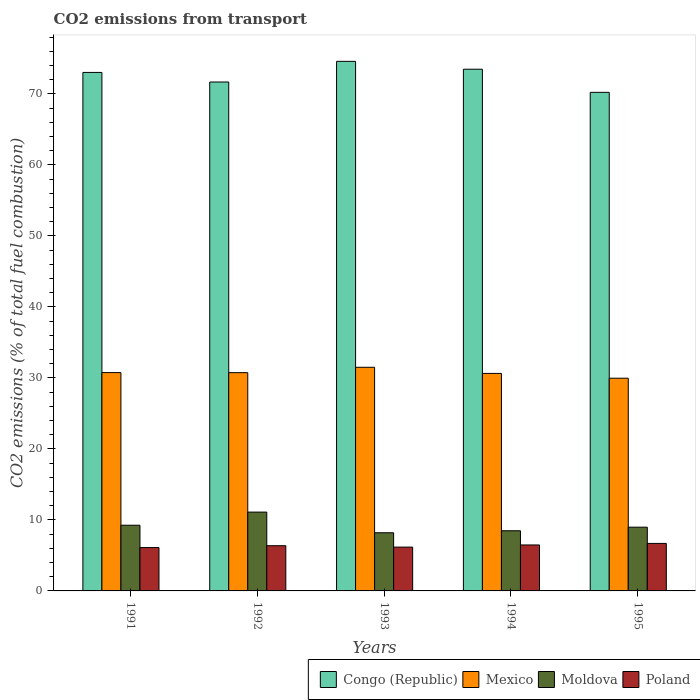How many groups of bars are there?
Your response must be concise. 5. Are the number of bars per tick equal to the number of legend labels?
Your answer should be very brief. Yes. Are the number of bars on each tick of the X-axis equal?
Offer a very short reply. Yes. How many bars are there on the 2nd tick from the left?
Give a very brief answer. 4. What is the label of the 1st group of bars from the left?
Keep it short and to the point. 1991. In how many cases, is the number of bars for a given year not equal to the number of legend labels?
Provide a succinct answer. 0. What is the total CO2 emitted in Mexico in 1991?
Provide a short and direct response. 30.75. Across all years, what is the maximum total CO2 emitted in Congo (Republic)?
Ensure brevity in your answer.  74.58. Across all years, what is the minimum total CO2 emitted in Congo (Republic)?
Your response must be concise. 70.21. In which year was the total CO2 emitted in Poland maximum?
Make the answer very short. 1995. What is the total total CO2 emitted in Moldova in the graph?
Offer a terse response. 45.99. What is the difference between the total CO2 emitted in Poland in 1992 and that in 1994?
Give a very brief answer. -0.1. What is the difference between the total CO2 emitted in Poland in 1993 and the total CO2 emitted in Congo (Republic) in 1994?
Make the answer very short. -67.3. What is the average total CO2 emitted in Congo (Republic) per year?
Your response must be concise. 72.59. In the year 1992, what is the difference between the total CO2 emitted in Poland and total CO2 emitted in Moldova?
Keep it short and to the point. -4.73. What is the ratio of the total CO2 emitted in Mexico in 1991 to that in 1995?
Provide a short and direct response. 1.03. Is the difference between the total CO2 emitted in Poland in 1992 and 1994 greater than the difference between the total CO2 emitted in Moldova in 1992 and 1994?
Keep it short and to the point. No. What is the difference between the highest and the second highest total CO2 emitted in Poland?
Offer a very short reply. 0.22. What is the difference between the highest and the lowest total CO2 emitted in Congo (Republic)?
Your answer should be very brief. 4.36. Is the sum of the total CO2 emitted in Mexico in 1991 and 1995 greater than the maximum total CO2 emitted in Moldova across all years?
Offer a very short reply. Yes. Is it the case that in every year, the sum of the total CO2 emitted in Moldova and total CO2 emitted in Congo (Republic) is greater than the sum of total CO2 emitted in Mexico and total CO2 emitted in Poland?
Your answer should be compact. Yes. What does the 2nd bar from the right in 1991 represents?
Your answer should be very brief. Moldova. Is it the case that in every year, the sum of the total CO2 emitted in Moldova and total CO2 emitted in Poland is greater than the total CO2 emitted in Congo (Republic)?
Provide a short and direct response. No. Are the values on the major ticks of Y-axis written in scientific E-notation?
Your answer should be compact. No. Does the graph contain grids?
Provide a short and direct response. No. How are the legend labels stacked?
Offer a terse response. Horizontal. What is the title of the graph?
Keep it short and to the point. CO2 emissions from transport. Does "Andorra" appear as one of the legend labels in the graph?
Offer a very short reply. No. What is the label or title of the X-axis?
Provide a succinct answer. Years. What is the label or title of the Y-axis?
Provide a short and direct response. CO2 emissions (% of total fuel combustion). What is the CO2 emissions (% of total fuel combustion) in Congo (Republic) in 1991?
Keep it short and to the point. 73.02. What is the CO2 emissions (% of total fuel combustion) in Mexico in 1991?
Your response must be concise. 30.75. What is the CO2 emissions (% of total fuel combustion) of Moldova in 1991?
Provide a short and direct response. 9.25. What is the CO2 emissions (% of total fuel combustion) in Poland in 1991?
Provide a succinct answer. 6.1. What is the CO2 emissions (% of total fuel combustion) of Congo (Republic) in 1992?
Your response must be concise. 71.67. What is the CO2 emissions (% of total fuel combustion) in Mexico in 1992?
Offer a very short reply. 30.74. What is the CO2 emissions (% of total fuel combustion) in Moldova in 1992?
Ensure brevity in your answer.  11.1. What is the CO2 emissions (% of total fuel combustion) of Poland in 1992?
Give a very brief answer. 6.37. What is the CO2 emissions (% of total fuel combustion) of Congo (Republic) in 1993?
Your response must be concise. 74.58. What is the CO2 emissions (% of total fuel combustion) in Mexico in 1993?
Offer a very short reply. 31.49. What is the CO2 emissions (% of total fuel combustion) in Moldova in 1993?
Make the answer very short. 8.19. What is the CO2 emissions (% of total fuel combustion) in Poland in 1993?
Provide a short and direct response. 6.17. What is the CO2 emissions (% of total fuel combustion) in Congo (Republic) in 1994?
Give a very brief answer. 73.47. What is the CO2 emissions (% of total fuel combustion) of Mexico in 1994?
Make the answer very short. 30.63. What is the CO2 emissions (% of total fuel combustion) of Moldova in 1994?
Ensure brevity in your answer.  8.47. What is the CO2 emissions (% of total fuel combustion) of Poland in 1994?
Provide a short and direct response. 6.47. What is the CO2 emissions (% of total fuel combustion) in Congo (Republic) in 1995?
Give a very brief answer. 70.21. What is the CO2 emissions (% of total fuel combustion) in Mexico in 1995?
Provide a short and direct response. 29.95. What is the CO2 emissions (% of total fuel combustion) of Moldova in 1995?
Make the answer very short. 8.98. What is the CO2 emissions (% of total fuel combustion) of Poland in 1995?
Make the answer very short. 6.69. Across all years, what is the maximum CO2 emissions (% of total fuel combustion) of Congo (Republic)?
Make the answer very short. 74.58. Across all years, what is the maximum CO2 emissions (% of total fuel combustion) of Mexico?
Provide a succinct answer. 31.49. Across all years, what is the maximum CO2 emissions (% of total fuel combustion) in Moldova?
Ensure brevity in your answer.  11.1. Across all years, what is the maximum CO2 emissions (% of total fuel combustion) in Poland?
Provide a succinct answer. 6.69. Across all years, what is the minimum CO2 emissions (% of total fuel combustion) of Congo (Republic)?
Ensure brevity in your answer.  70.21. Across all years, what is the minimum CO2 emissions (% of total fuel combustion) in Mexico?
Ensure brevity in your answer.  29.95. Across all years, what is the minimum CO2 emissions (% of total fuel combustion) in Moldova?
Offer a terse response. 8.19. Across all years, what is the minimum CO2 emissions (% of total fuel combustion) of Poland?
Offer a very short reply. 6.1. What is the total CO2 emissions (% of total fuel combustion) in Congo (Republic) in the graph?
Your response must be concise. 362.94. What is the total CO2 emissions (% of total fuel combustion) in Mexico in the graph?
Make the answer very short. 153.56. What is the total CO2 emissions (% of total fuel combustion) in Moldova in the graph?
Your answer should be very brief. 45.99. What is the total CO2 emissions (% of total fuel combustion) of Poland in the graph?
Ensure brevity in your answer.  31.8. What is the difference between the CO2 emissions (% of total fuel combustion) of Congo (Republic) in 1991 and that in 1992?
Make the answer very short. 1.35. What is the difference between the CO2 emissions (% of total fuel combustion) in Mexico in 1991 and that in 1992?
Provide a short and direct response. 0.01. What is the difference between the CO2 emissions (% of total fuel combustion) in Moldova in 1991 and that in 1992?
Offer a terse response. -1.85. What is the difference between the CO2 emissions (% of total fuel combustion) in Poland in 1991 and that in 1992?
Make the answer very short. -0.26. What is the difference between the CO2 emissions (% of total fuel combustion) of Congo (Republic) in 1991 and that in 1993?
Give a very brief answer. -1.56. What is the difference between the CO2 emissions (% of total fuel combustion) of Mexico in 1991 and that in 1993?
Your response must be concise. -0.75. What is the difference between the CO2 emissions (% of total fuel combustion) in Moldova in 1991 and that in 1993?
Keep it short and to the point. 1.06. What is the difference between the CO2 emissions (% of total fuel combustion) in Poland in 1991 and that in 1993?
Make the answer very short. -0.07. What is the difference between the CO2 emissions (% of total fuel combustion) of Congo (Republic) in 1991 and that in 1994?
Provide a succinct answer. -0.45. What is the difference between the CO2 emissions (% of total fuel combustion) of Mexico in 1991 and that in 1994?
Provide a succinct answer. 0.12. What is the difference between the CO2 emissions (% of total fuel combustion) in Moldova in 1991 and that in 1994?
Your response must be concise. 0.78. What is the difference between the CO2 emissions (% of total fuel combustion) of Poland in 1991 and that in 1994?
Offer a very short reply. -0.37. What is the difference between the CO2 emissions (% of total fuel combustion) in Congo (Republic) in 1991 and that in 1995?
Your answer should be very brief. 2.8. What is the difference between the CO2 emissions (% of total fuel combustion) in Mexico in 1991 and that in 1995?
Offer a terse response. 0.79. What is the difference between the CO2 emissions (% of total fuel combustion) in Moldova in 1991 and that in 1995?
Your answer should be very brief. 0.28. What is the difference between the CO2 emissions (% of total fuel combustion) of Poland in 1991 and that in 1995?
Make the answer very short. -0.58. What is the difference between the CO2 emissions (% of total fuel combustion) in Congo (Republic) in 1992 and that in 1993?
Offer a very short reply. -2.91. What is the difference between the CO2 emissions (% of total fuel combustion) of Mexico in 1992 and that in 1993?
Keep it short and to the point. -0.76. What is the difference between the CO2 emissions (% of total fuel combustion) in Moldova in 1992 and that in 1993?
Make the answer very short. 2.91. What is the difference between the CO2 emissions (% of total fuel combustion) in Poland in 1992 and that in 1993?
Provide a succinct answer. 0.2. What is the difference between the CO2 emissions (% of total fuel combustion) of Congo (Republic) in 1992 and that in 1994?
Offer a very short reply. -1.8. What is the difference between the CO2 emissions (% of total fuel combustion) of Mexico in 1992 and that in 1994?
Provide a succinct answer. 0.11. What is the difference between the CO2 emissions (% of total fuel combustion) of Moldova in 1992 and that in 1994?
Keep it short and to the point. 2.63. What is the difference between the CO2 emissions (% of total fuel combustion) of Poland in 1992 and that in 1994?
Give a very brief answer. -0.1. What is the difference between the CO2 emissions (% of total fuel combustion) of Congo (Republic) in 1992 and that in 1995?
Offer a very short reply. 1.45. What is the difference between the CO2 emissions (% of total fuel combustion) in Mexico in 1992 and that in 1995?
Your response must be concise. 0.78. What is the difference between the CO2 emissions (% of total fuel combustion) in Moldova in 1992 and that in 1995?
Your answer should be compact. 2.12. What is the difference between the CO2 emissions (% of total fuel combustion) in Poland in 1992 and that in 1995?
Provide a short and direct response. -0.32. What is the difference between the CO2 emissions (% of total fuel combustion) of Congo (Republic) in 1993 and that in 1994?
Offer a terse response. 1.11. What is the difference between the CO2 emissions (% of total fuel combustion) of Mexico in 1993 and that in 1994?
Provide a succinct answer. 0.86. What is the difference between the CO2 emissions (% of total fuel combustion) in Moldova in 1993 and that in 1994?
Keep it short and to the point. -0.28. What is the difference between the CO2 emissions (% of total fuel combustion) of Poland in 1993 and that in 1994?
Give a very brief answer. -0.3. What is the difference between the CO2 emissions (% of total fuel combustion) in Congo (Republic) in 1993 and that in 1995?
Make the answer very short. 4.36. What is the difference between the CO2 emissions (% of total fuel combustion) in Mexico in 1993 and that in 1995?
Your answer should be very brief. 1.54. What is the difference between the CO2 emissions (% of total fuel combustion) of Moldova in 1993 and that in 1995?
Your response must be concise. -0.79. What is the difference between the CO2 emissions (% of total fuel combustion) in Poland in 1993 and that in 1995?
Offer a very short reply. -0.52. What is the difference between the CO2 emissions (% of total fuel combustion) in Congo (Republic) in 1994 and that in 1995?
Offer a terse response. 3.26. What is the difference between the CO2 emissions (% of total fuel combustion) of Mexico in 1994 and that in 1995?
Give a very brief answer. 0.68. What is the difference between the CO2 emissions (% of total fuel combustion) in Moldova in 1994 and that in 1995?
Provide a short and direct response. -0.5. What is the difference between the CO2 emissions (% of total fuel combustion) in Poland in 1994 and that in 1995?
Your response must be concise. -0.22. What is the difference between the CO2 emissions (% of total fuel combustion) in Congo (Republic) in 1991 and the CO2 emissions (% of total fuel combustion) in Mexico in 1992?
Offer a very short reply. 42.28. What is the difference between the CO2 emissions (% of total fuel combustion) in Congo (Republic) in 1991 and the CO2 emissions (% of total fuel combustion) in Moldova in 1992?
Provide a short and direct response. 61.92. What is the difference between the CO2 emissions (% of total fuel combustion) of Congo (Republic) in 1991 and the CO2 emissions (% of total fuel combustion) of Poland in 1992?
Provide a short and direct response. 66.65. What is the difference between the CO2 emissions (% of total fuel combustion) of Mexico in 1991 and the CO2 emissions (% of total fuel combustion) of Moldova in 1992?
Provide a short and direct response. 19.65. What is the difference between the CO2 emissions (% of total fuel combustion) of Mexico in 1991 and the CO2 emissions (% of total fuel combustion) of Poland in 1992?
Offer a very short reply. 24.38. What is the difference between the CO2 emissions (% of total fuel combustion) of Moldova in 1991 and the CO2 emissions (% of total fuel combustion) of Poland in 1992?
Ensure brevity in your answer.  2.88. What is the difference between the CO2 emissions (% of total fuel combustion) of Congo (Republic) in 1991 and the CO2 emissions (% of total fuel combustion) of Mexico in 1993?
Give a very brief answer. 41.52. What is the difference between the CO2 emissions (% of total fuel combustion) of Congo (Republic) in 1991 and the CO2 emissions (% of total fuel combustion) of Moldova in 1993?
Provide a succinct answer. 64.83. What is the difference between the CO2 emissions (% of total fuel combustion) of Congo (Republic) in 1991 and the CO2 emissions (% of total fuel combustion) of Poland in 1993?
Offer a very short reply. 66.85. What is the difference between the CO2 emissions (% of total fuel combustion) in Mexico in 1991 and the CO2 emissions (% of total fuel combustion) in Moldova in 1993?
Keep it short and to the point. 22.56. What is the difference between the CO2 emissions (% of total fuel combustion) in Mexico in 1991 and the CO2 emissions (% of total fuel combustion) in Poland in 1993?
Offer a very short reply. 24.57. What is the difference between the CO2 emissions (% of total fuel combustion) of Moldova in 1991 and the CO2 emissions (% of total fuel combustion) of Poland in 1993?
Keep it short and to the point. 3.08. What is the difference between the CO2 emissions (% of total fuel combustion) in Congo (Republic) in 1991 and the CO2 emissions (% of total fuel combustion) in Mexico in 1994?
Ensure brevity in your answer.  42.39. What is the difference between the CO2 emissions (% of total fuel combustion) in Congo (Republic) in 1991 and the CO2 emissions (% of total fuel combustion) in Moldova in 1994?
Provide a short and direct response. 64.54. What is the difference between the CO2 emissions (% of total fuel combustion) of Congo (Republic) in 1991 and the CO2 emissions (% of total fuel combustion) of Poland in 1994?
Provide a short and direct response. 66.54. What is the difference between the CO2 emissions (% of total fuel combustion) in Mexico in 1991 and the CO2 emissions (% of total fuel combustion) in Moldova in 1994?
Your response must be concise. 22.27. What is the difference between the CO2 emissions (% of total fuel combustion) in Mexico in 1991 and the CO2 emissions (% of total fuel combustion) in Poland in 1994?
Your answer should be very brief. 24.27. What is the difference between the CO2 emissions (% of total fuel combustion) in Moldova in 1991 and the CO2 emissions (% of total fuel combustion) in Poland in 1994?
Keep it short and to the point. 2.78. What is the difference between the CO2 emissions (% of total fuel combustion) of Congo (Republic) in 1991 and the CO2 emissions (% of total fuel combustion) of Mexico in 1995?
Your answer should be compact. 43.06. What is the difference between the CO2 emissions (% of total fuel combustion) of Congo (Republic) in 1991 and the CO2 emissions (% of total fuel combustion) of Moldova in 1995?
Ensure brevity in your answer.  64.04. What is the difference between the CO2 emissions (% of total fuel combustion) of Congo (Republic) in 1991 and the CO2 emissions (% of total fuel combustion) of Poland in 1995?
Offer a terse response. 66.33. What is the difference between the CO2 emissions (% of total fuel combustion) in Mexico in 1991 and the CO2 emissions (% of total fuel combustion) in Moldova in 1995?
Your answer should be very brief. 21.77. What is the difference between the CO2 emissions (% of total fuel combustion) of Mexico in 1991 and the CO2 emissions (% of total fuel combustion) of Poland in 1995?
Provide a short and direct response. 24.06. What is the difference between the CO2 emissions (% of total fuel combustion) in Moldova in 1991 and the CO2 emissions (% of total fuel combustion) in Poland in 1995?
Keep it short and to the point. 2.56. What is the difference between the CO2 emissions (% of total fuel combustion) in Congo (Republic) in 1992 and the CO2 emissions (% of total fuel combustion) in Mexico in 1993?
Offer a very short reply. 40.17. What is the difference between the CO2 emissions (% of total fuel combustion) of Congo (Republic) in 1992 and the CO2 emissions (% of total fuel combustion) of Moldova in 1993?
Offer a terse response. 63.48. What is the difference between the CO2 emissions (% of total fuel combustion) in Congo (Republic) in 1992 and the CO2 emissions (% of total fuel combustion) in Poland in 1993?
Your answer should be very brief. 65.5. What is the difference between the CO2 emissions (% of total fuel combustion) of Mexico in 1992 and the CO2 emissions (% of total fuel combustion) of Moldova in 1993?
Provide a succinct answer. 22.55. What is the difference between the CO2 emissions (% of total fuel combustion) of Mexico in 1992 and the CO2 emissions (% of total fuel combustion) of Poland in 1993?
Your response must be concise. 24.57. What is the difference between the CO2 emissions (% of total fuel combustion) in Moldova in 1992 and the CO2 emissions (% of total fuel combustion) in Poland in 1993?
Your answer should be very brief. 4.93. What is the difference between the CO2 emissions (% of total fuel combustion) in Congo (Republic) in 1992 and the CO2 emissions (% of total fuel combustion) in Mexico in 1994?
Make the answer very short. 41.04. What is the difference between the CO2 emissions (% of total fuel combustion) in Congo (Republic) in 1992 and the CO2 emissions (% of total fuel combustion) in Moldova in 1994?
Your response must be concise. 63.19. What is the difference between the CO2 emissions (% of total fuel combustion) of Congo (Republic) in 1992 and the CO2 emissions (% of total fuel combustion) of Poland in 1994?
Ensure brevity in your answer.  65.19. What is the difference between the CO2 emissions (% of total fuel combustion) of Mexico in 1992 and the CO2 emissions (% of total fuel combustion) of Moldova in 1994?
Your answer should be very brief. 22.26. What is the difference between the CO2 emissions (% of total fuel combustion) of Mexico in 1992 and the CO2 emissions (% of total fuel combustion) of Poland in 1994?
Your response must be concise. 24.26. What is the difference between the CO2 emissions (% of total fuel combustion) in Moldova in 1992 and the CO2 emissions (% of total fuel combustion) in Poland in 1994?
Offer a terse response. 4.63. What is the difference between the CO2 emissions (% of total fuel combustion) of Congo (Republic) in 1992 and the CO2 emissions (% of total fuel combustion) of Mexico in 1995?
Your answer should be compact. 41.71. What is the difference between the CO2 emissions (% of total fuel combustion) of Congo (Republic) in 1992 and the CO2 emissions (% of total fuel combustion) of Moldova in 1995?
Provide a short and direct response. 62.69. What is the difference between the CO2 emissions (% of total fuel combustion) of Congo (Republic) in 1992 and the CO2 emissions (% of total fuel combustion) of Poland in 1995?
Keep it short and to the point. 64.98. What is the difference between the CO2 emissions (% of total fuel combustion) of Mexico in 1992 and the CO2 emissions (% of total fuel combustion) of Moldova in 1995?
Your response must be concise. 21.76. What is the difference between the CO2 emissions (% of total fuel combustion) of Mexico in 1992 and the CO2 emissions (% of total fuel combustion) of Poland in 1995?
Keep it short and to the point. 24.05. What is the difference between the CO2 emissions (% of total fuel combustion) in Moldova in 1992 and the CO2 emissions (% of total fuel combustion) in Poland in 1995?
Offer a terse response. 4.41. What is the difference between the CO2 emissions (% of total fuel combustion) in Congo (Republic) in 1993 and the CO2 emissions (% of total fuel combustion) in Mexico in 1994?
Your answer should be very brief. 43.95. What is the difference between the CO2 emissions (% of total fuel combustion) of Congo (Republic) in 1993 and the CO2 emissions (% of total fuel combustion) of Moldova in 1994?
Provide a succinct answer. 66.1. What is the difference between the CO2 emissions (% of total fuel combustion) of Congo (Republic) in 1993 and the CO2 emissions (% of total fuel combustion) of Poland in 1994?
Offer a very short reply. 68.1. What is the difference between the CO2 emissions (% of total fuel combustion) in Mexico in 1993 and the CO2 emissions (% of total fuel combustion) in Moldova in 1994?
Ensure brevity in your answer.  23.02. What is the difference between the CO2 emissions (% of total fuel combustion) of Mexico in 1993 and the CO2 emissions (% of total fuel combustion) of Poland in 1994?
Make the answer very short. 25.02. What is the difference between the CO2 emissions (% of total fuel combustion) of Moldova in 1993 and the CO2 emissions (% of total fuel combustion) of Poland in 1994?
Your answer should be compact. 1.72. What is the difference between the CO2 emissions (% of total fuel combustion) of Congo (Republic) in 1993 and the CO2 emissions (% of total fuel combustion) of Mexico in 1995?
Offer a terse response. 44.62. What is the difference between the CO2 emissions (% of total fuel combustion) in Congo (Republic) in 1993 and the CO2 emissions (% of total fuel combustion) in Moldova in 1995?
Keep it short and to the point. 65.6. What is the difference between the CO2 emissions (% of total fuel combustion) in Congo (Republic) in 1993 and the CO2 emissions (% of total fuel combustion) in Poland in 1995?
Your answer should be very brief. 67.89. What is the difference between the CO2 emissions (% of total fuel combustion) in Mexico in 1993 and the CO2 emissions (% of total fuel combustion) in Moldova in 1995?
Your response must be concise. 22.52. What is the difference between the CO2 emissions (% of total fuel combustion) of Mexico in 1993 and the CO2 emissions (% of total fuel combustion) of Poland in 1995?
Make the answer very short. 24.8. What is the difference between the CO2 emissions (% of total fuel combustion) of Moldova in 1993 and the CO2 emissions (% of total fuel combustion) of Poland in 1995?
Make the answer very short. 1.5. What is the difference between the CO2 emissions (% of total fuel combustion) in Congo (Republic) in 1994 and the CO2 emissions (% of total fuel combustion) in Mexico in 1995?
Give a very brief answer. 43.51. What is the difference between the CO2 emissions (% of total fuel combustion) of Congo (Republic) in 1994 and the CO2 emissions (% of total fuel combustion) of Moldova in 1995?
Make the answer very short. 64.49. What is the difference between the CO2 emissions (% of total fuel combustion) in Congo (Republic) in 1994 and the CO2 emissions (% of total fuel combustion) in Poland in 1995?
Your answer should be very brief. 66.78. What is the difference between the CO2 emissions (% of total fuel combustion) of Mexico in 1994 and the CO2 emissions (% of total fuel combustion) of Moldova in 1995?
Your answer should be very brief. 21.65. What is the difference between the CO2 emissions (% of total fuel combustion) in Mexico in 1994 and the CO2 emissions (% of total fuel combustion) in Poland in 1995?
Offer a very short reply. 23.94. What is the difference between the CO2 emissions (% of total fuel combustion) in Moldova in 1994 and the CO2 emissions (% of total fuel combustion) in Poland in 1995?
Your answer should be compact. 1.78. What is the average CO2 emissions (% of total fuel combustion) of Congo (Republic) per year?
Provide a short and direct response. 72.59. What is the average CO2 emissions (% of total fuel combustion) in Mexico per year?
Your response must be concise. 30.71. What is the average CO2 emissions (% of total fuel combustion) of Moldova per year?
Offer a terse response. 9.2. What is the average CO2 emissions (% of total fuel combustion) in Poland per year?
Make the answer very short. 6.36. In the year 1991, what is the difference between the CO2 emissions (% of total fuel combustion) of Congo (Republic) and CO2 emissions (% of total fuel combustion) of Mexico?
Offer a terse response. 42.27. In the year 1991, what is the difference between the CO2 emissions (% of total fuel combustion) in Congo (Republic) and CO2 emissions (% of total fuel combustion) in Moldova?
Provide a succinct answer. 63.76. In the year 1991, what is the difference between the CO2 emissions (% of total fuel combustion) of Congo (Republic) and CO2 emissions (% of total fuel combustion) of Poland?
Ensure brevity in your answer.  66.91. In the year 1991, what is the difference between the CO2 emissions (% of total fuel combustion) of Mexico and CO2 emissions (% of total fuel combustion) of Moldova?
Your answer should be very brief. 21.49. In the year 1991, what is the difference between the CO2 emissions (% of total fuel combustion) of Mexico and CO2 emissions (% of total fuel combustion) of Poland?
Your answer should be very brief. 24.64. In the year 1991, what is the difference between the CO2 emissions (% of total fuel combustion) of Moldova and CO2 emissions (% of total fuel combustion) of Poland?
Provide a succinct answer. 3.15. In the year 1992, what is the difference between the CO2 emissions (% of total fuel combustion) in Congo (Republic) and CO2 emissions (% of total fuel combustion) in Mexico?
Your answer should be very brief. 40.93. In the year 1992, what is the difference between the CO2 emissions (% of total fuel combustion) of Congo (Republic) and CO2 emissions (% of total fuel combustion) of Moldova?
Keep it short and to the point. 60.57. In the year 1992, what is the difference between the CO2 emissions (% of total fuel combustion) in Congo (Republic) and CO2 emissions (% of total fuel combustion) in Poland?
Offer a terse response. 65.3. In the year 1992, what is the difference between the CO2 emissions (% of total fuel combustion) of Mexico and CO2 emissions (% of total fuel combustion) of Moldova?
Make the answer very short. 19.64. In the year 1992, what is the difference between the CO2 emissions (% of total fuel combustion) in Mexico and CO2 emissions (% of total fuel combustion) in Poland?
Offer a terse response. 24.37. In the year 1992, what is the difference between the CO2 emissions (% of total fuel combustion) of Moldova and CO2 emissions (% of total fuel combustion) of Poland?
Keep it short and to the point. 4.73. In the year 1993, what is the difference between the CO2 emissions (% of total fuel combustion) in Congo (Republic) and CO2 emissions (% of total fuel combustion) in Mexico?
Your answer should be very brief. 43.08. In the year 1993, what is the difference between the CO2 emissions (% of total fuel combustion) in Congo (Republic) and CO2 emissions (% of total fuel combustion) in Moldova?
Offer a terse response. 66.39. In the year 1993, what is the difference between the CO2 emissions (% of total fuel combustion) in Congo (Republic) and CO2 emissions (% of total fuel combustion) in Poland?
Ensure brevity in your answer.  68.41. In the year 1993, what is the difference between the CO2 emissions (% of total fuel combustion) of Mexico and CO2 emissions (% of total fuel combustion) of Moldova?
Your answer should be compact. 23.3. In the year 1993, what is the difference between the CO2 emissions (% of total fuel combustion) of Mexico and CO2 emissions (% of total fuel combustion) of Poland?
Provide a short and direct response. 25.32. In the year 1993, what is the difference between the CO2 emissions (% of total fuel combustion) of Moldova and CO2 emissions (% of total fuel combustion) of Poland?
Keep it short and to the point. 2.02. In the year 1994, what is the difference between the CO2 emissions (% of total fuel combustion) in Congo (Republic) and CO2 emissions (% of total fuel combustion) in Mexico?
Keep it short and to the point. 42.84. In the year 1994, what is the difference between the CO2 emissions (% of total fuel combustion) in Congo (Republic) and CO2 emissions (% of total fuel combustion) in Moldova?
Offer a very short reply. 65. In the year 1994, what is the difference between the CO2 emissions (% of total fuel combustion) in Congo (Republic) and CO2 emissions (% of total fuel combustion) in Poland?
Give a very brief answer. 67. In the year 1994, what is the difference between the CO2 emissions (% of total fuel combustion) of Mexico and CO2 emissions (% of total fuel combustion) of Moldova?
Offer a terse response. 22.16. In the year 1994, what is the difference between the CO2 emissions (% of total fuel combustion) of Mexico and CO2 emissions (% of total fuel combustion) of Poland?
Make the answer very short. 24.16. In the year 1994, what is the difference between the CO2 emissions (% of total fuel combustion) in Moldova and CO2 emissions (% of total fuel combustion) in Poland?
Offer a terse response. 2. In the year 1995, what is the difference between the CO2 emissions (% of total fuel combustion) of Congo (Republic) and CO2 emissions (% of total fuel combustion) of Mexico?
Keep it short and to the point. 40.26. In the year 1995, what is the difference between the CO2 emissions (% of total fuel combustion) in Congo (Republic) and CO2 emissions (% of total fuel combustion) in Moldova?
Offer a very short reply. 61.24. In the year 1995, what is the difference between the CO2 emissions (% of total fuel combustion) of Congo (Republic) and CO2 emissions (% of total fuel combustion) of Poland?
Keep it short and to the point. 63.52. In the year 1995, what is the difference between the CO2 emissions (% of total fuel combustion) of Mexico and CO2 emissions (% of total fuel combustion) of Moldova?
Make the answer very short. 20.98. In the year 1995, what is the difference between the CO2 emissions (% of total fuel combustion) in Mexico and CO2 emissions (% of total fuel combustion) in Poland?
Provide a succinct answer. 23.27. In the year 1995, what is the difference between the CO2 emissions (% of total fuel combustion) in Moldova and CO2 emissions (% of total fuel combustion) in Poland?
Offer a terse response. 2.29. What is the ratio of the CO2 emissions (% of total fuel combustion) of Congo (Republic) in 1991 to that in 1992?
Offer a terse response. 1.02. What is the ratio of the CO2 emissions (% of total fuel combustion) of Mexico in 1991 to that in 1992?
Offer a terse response. 1. What is the ratio of the CO2 emissions (% of total fuel combustion) of Moldova in 1991 to that in 1992?
Offer a terse response. 0.83. What is the ratio of the CO2 emissions (% of total fuel combustion) of Poland in 1991 to that in 1992?
Make the answer very short. 0.96. What is the ratio of the CO2 emissions (% of total fuel combustion) in Congo (Republic) in 1991 to that in 1993?
Offer a terse response. 0.98. What is the ratio of the CO2 emissions (% of total fuel combustion) in Mexico in 1991 to that in 1993?
Offer a terse response. 0.98. What is the ratio of the CO2 emissions (% of total fuel combustion) in Moldova in 1991 to that in 1993?
Give a very brief answer. 1.13. What is the ratio of the CO2 emissions (% of total fuel combustion) of Poland in 1991 to that in 1993?
Your response must be concise. 0.99. What is the ratio of the CO2 emissions (% of total fuel combustion) of Congo (Republic) in 1991 to that in 1994?
Your response must be concise. 0.99. What is the ratio of the CO2 emissions (% of total fuel combustion) in Mexico in 1991 to that in 1994?
Give a very brief answer. 1. What is the ratio of the CO2 emissions (% of total fuel combustion) in Moldova in 1991 to that in 1994?
Your response must be concise. 1.09. What is the ratio of the CO2 emissions (% of total fuel combustion) of Poland in 1991 to that in 1994?
Give a very brief answer. 0.94. What is the ratio of the CO2 emissions (% of total fuel combustion) of Congo (Republic) in 1991 to that in 1995?
Offer a terse response. 1.04. What is the ratio of the CO2 emissions (% of total fuel combustion) of Mexico in 1991 to that in 1995?
Offer a terse response. 1.03. What is the ratio of the CO2 emissions (% of total fuel combustion) in Moldova in 1991 to that in 1995?
Make the answer very short. 1.03. What is the ratio of the CO2 emissions (% of total fuel combustion) in Poland in 1991 to that in 1995?
Keep it short and to the point. 0.91. What is the ratio of the CO2 emissions (% of total fuel combustion) in Congo (Republic) in 1992 to that in 1993?
Make the answer very short. 0.96. What is the ratio of the CO2 emissions (% of total fuel combustion) of Mexico in 1992 to that in 1993?
Your answer should be very brief. 0.98. What is the ratio of the CO2 emissions (% of total fuel combustion) of Moldova in 1992 to that in 1993?
Ensure brevity in your answer.  1.36. What is the ratio of the CO2 emissions (% of total fuel combustion) in Poland in 1992 to that in 1993?
Provide a short and direct response. 1.03. What is the ratio of the CO2 emissions (% of total fuel combustion) in Congo (Republic) in 1992 to that in 1994?
Keep it short and to the point. 0.98. What is the ratio of the CO2 emissions (% of total fuel combustion) of Mexico in 1992 to that in 1994?
Make the answer very short. 1. What is the ratio of the CO2 emissions (% of total fuel combustion) of Moldova in 1992 to that in 1994?
Your answer should be compact. 1.31. What is the ratio of the CO2 emissions (% of total fuel combustion) of Poland in 1992 to that in 1994?
Ensure brevity in your answer.  0.98. What is the ratio of the CO2 emissions (% of total fuel combustion) in Congo (Republic) in 1992 to that in 1995?
Your answer should be compact. 1.02. What is the ratio of the CO2 emissions (% of total fuel combustion) of Mexico in 1992 to that in 1995?
Offer a very short reply. 1.03. What is the ratio of the CO2 emissions (% of total fuel combustion) of Moldova in 1992 to that in 1995?
Provide a succinct answer. 1.24. What is the ratio of the CO2 emissions (% of total fuel combustion) in Poland in 1992 to that in 1995?
Provide a short and direct response. 0.95. What is the ratio of the CO2 emissions (% of total fuel combustion) of Congo (Republic) in 1993 to that in 1994?
Provide a succinct answer. 1.02. What is the ratio of the CO2 emissions (% of total fuel combustion) in Mexico in 1993 to that in 1994?
Keep it short and to the point. 1.03. What is the ratio of the CO2 emissions (% of total fuel combustion) in Moldova in 1993 to that in 1994?
Offer a terse response. 0.97. What is the ratio of the CO2 emissions (% of total fuel combustion) in Poland in 1993 to that in 1994?
Offer a terse response. 0.95. What is the ratio of the CO2 emissions (% of total fuel combustion) of Congo (Republic) in 1993 to that in 1995?
Offer a very short reply. 1.06. What is the ratio of the CO2 emissions (% of total fuel combustion) in Mexico in 1993 to that in 1995?
Keep it short and to the point. 1.05. What is the ratio of the CO2 emissions (% of total fuel combustion) of Moldova in 1993 to that in 1995?
Offer a very short reply. 0.91. What is the ratio of the CO2 emissions (% of total fuel combustion) of Poland in 1993 to that in 1995?
Make the answer very short. 0.92. What is the ratio of the CO2 emissions (% of total fuel combustion) of Congo (Republic) in 1994 to that in 1995?
Give a very brief answer. 1.05. What is the ratio of the CO2 emissions (% of total fuel combustion) of Mexico in 1994 to that in 1995?
Your answer should be compact. 1.02. What is the ratio of the CO2 emissions (% of total fuel combustion) in Moldova in 1994 to that in 1995?
Ensure brevity in your answer.  0.94. What is the ratio of the CO2 emissions (% of total fuel combustion) in Poland in 1994 to that in 1995?
Offer a terse response. 0.97. What is the difference between the highest and the second highest CO2 emissions (% of total fuel combustion) in Congo (Republic)?
Provide a short and direct response. 1.11. What is the difference between the highest and the second highest CO2 emissions (% of total fuel combustion) of Mexico?
Make the answer very short. 0.75. What is the difference between the highest and the second highest CO2 emissions (% of total fuel combustion) of Moldova?
Your response must be concise. 1.85. What is the difference between the highest and the second highest CO2 emissions (% of total fuel combustion) of Poland?
Your answer should be compact. 0.22. What is the difference between the highest and the lowest CO2 emissions (% of total fuel combustion) in Congo (Republic)?
Offer a terse response. 4.36. What is the difference between the highest and the lowest CO2 emissions (% of total fuel combustion) in Mexico?
Your answer should be compact. 1.54. What is the difference between the highest and the lowest CO2 emissions (% of total fuel combustion) of Moldova?
Offer a very short reply. 2.91. What is the difference between the highest and the lowest CO2 emissions (% of total fuel combustion) in Poland?
Offer a very short reply. 0.58. 